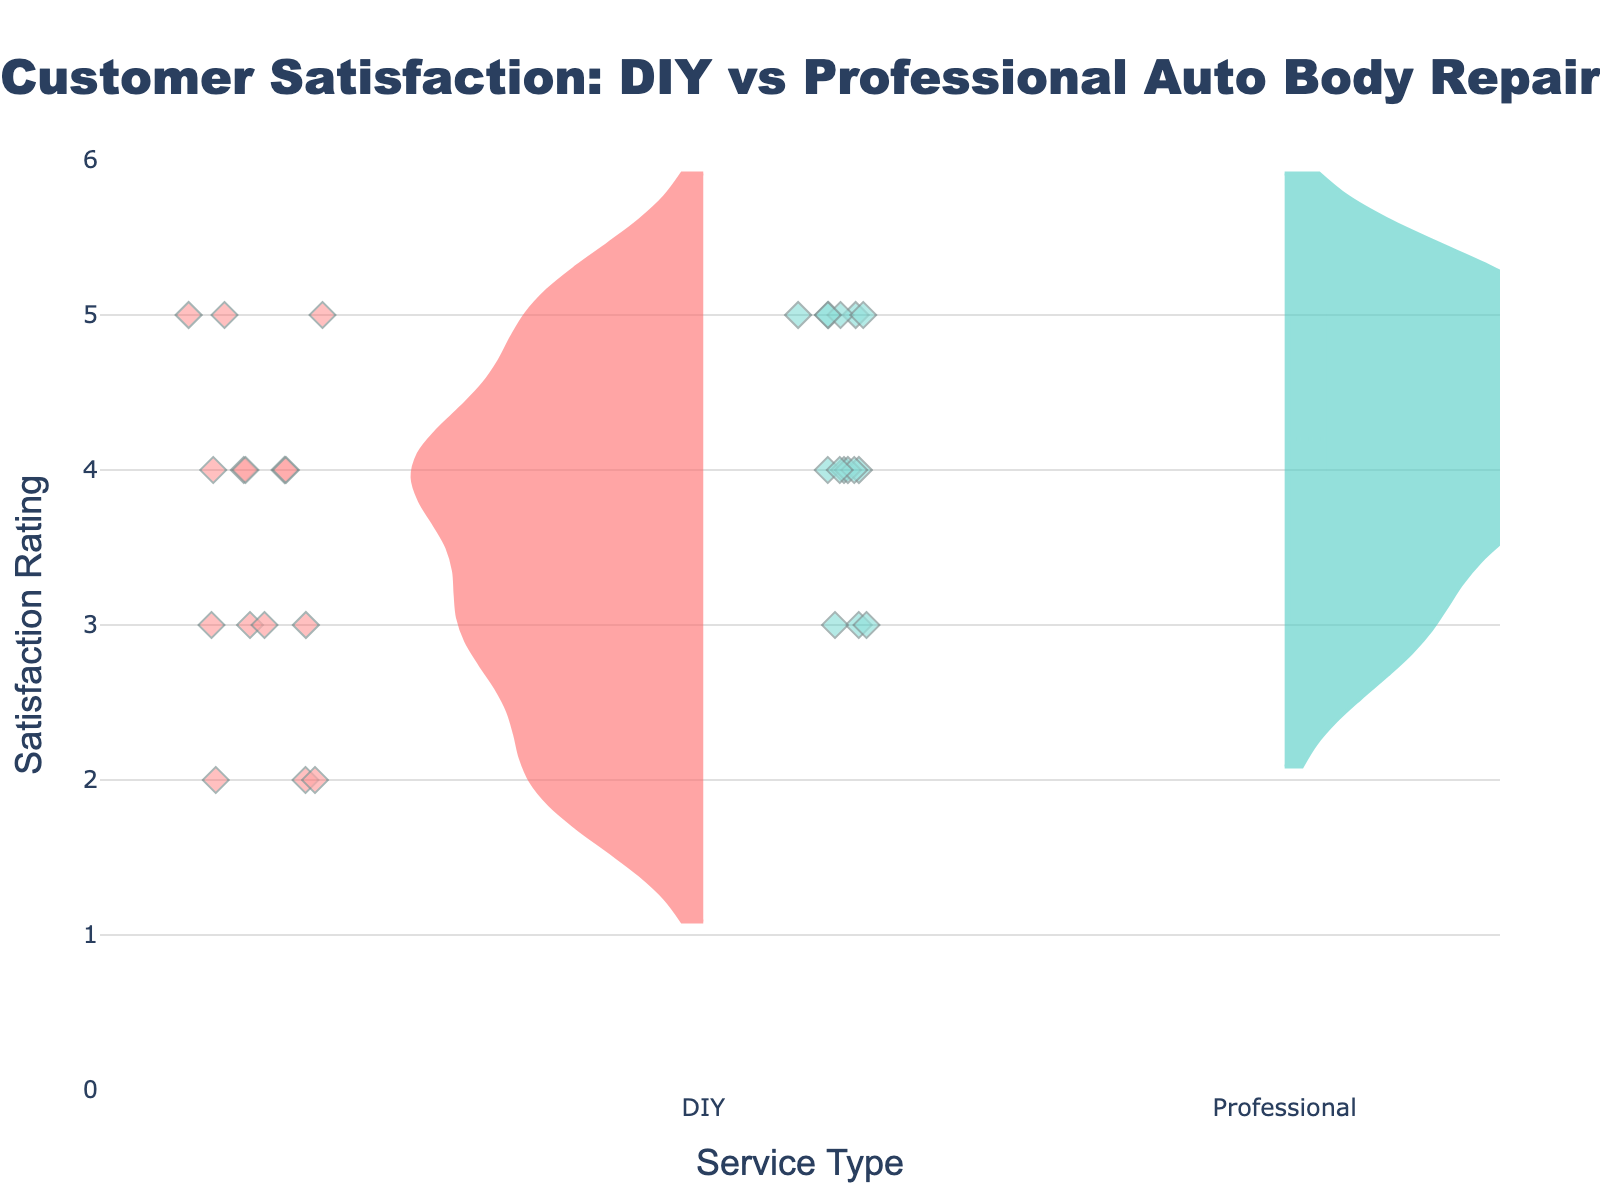what's the title of the figure? The title of the figure is placed at the top and is written in a large, bold font. It reads "Customer Satisfaction: DIY vs Professional Auto Body Repair."
Answer: Customer Satisfaction: DIY vs Professional Auto Body Repair What is the range of the y-axis? The y-axis of the figure starts at 0 and goes up to 6, as indicated by the y-axis range shown in the chart.
Answer: 0 to 6 Which service type has the highest satisfaction ratings? By comparing the two violin plots, the Professional service type consistently shows higher satisfaction ratings, mostly around 4 and 5.
Answer: Professional Are there any ratings below 3 for Professional services? The violin plot for Professional services does not extend below a rating of 3, indicating that there are no ratings below 3.
Answer: No What is the most common rating for DIY services? By looking at the density of the violin plot for DIY services, the most frequently occurring ratings are around 3 and 4.
Answer: 3 and 4 How does the distribution of ratings differ between DIY and Professional services? The DIY services have a wider spread of ratings, ranging from 2 to 5, while Professional services are more concentrated between 3 and 5, indicating more consistency and higher satisfaction.
Answer: DIY has a wider spread, Professional is more consistent Which service type shows a wider spread in satisfaction ratings? The violin plot for DIY services shows a wider spread in satisfaction ratings, extending from 2 to 5, whereas Professional services are mostly clustered between 3 and 5.
Answer: DIY How many ratings of 5 are given to DIY services? In the DIY violin plot, the number of diamond markers appearing at the y-value of 5 can be counted, and there are 4 such markers.
Answer: 4 What is the median rating for Professional services? Since professional ratings are concentrated around higher values, finding the median involves identifying the middle value in the ordered list of ratings, which is 4.
Answer: 4 